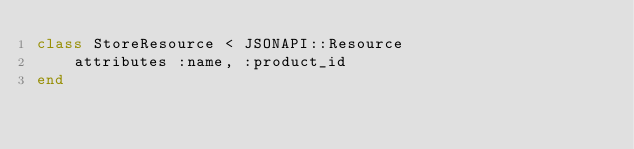<code> <loc_0><loc_0><loc_500><loc_500><_Ruby_>class StoreResource < JSONAPI::Resource 
    attributes :name, :product_id
end</code> 